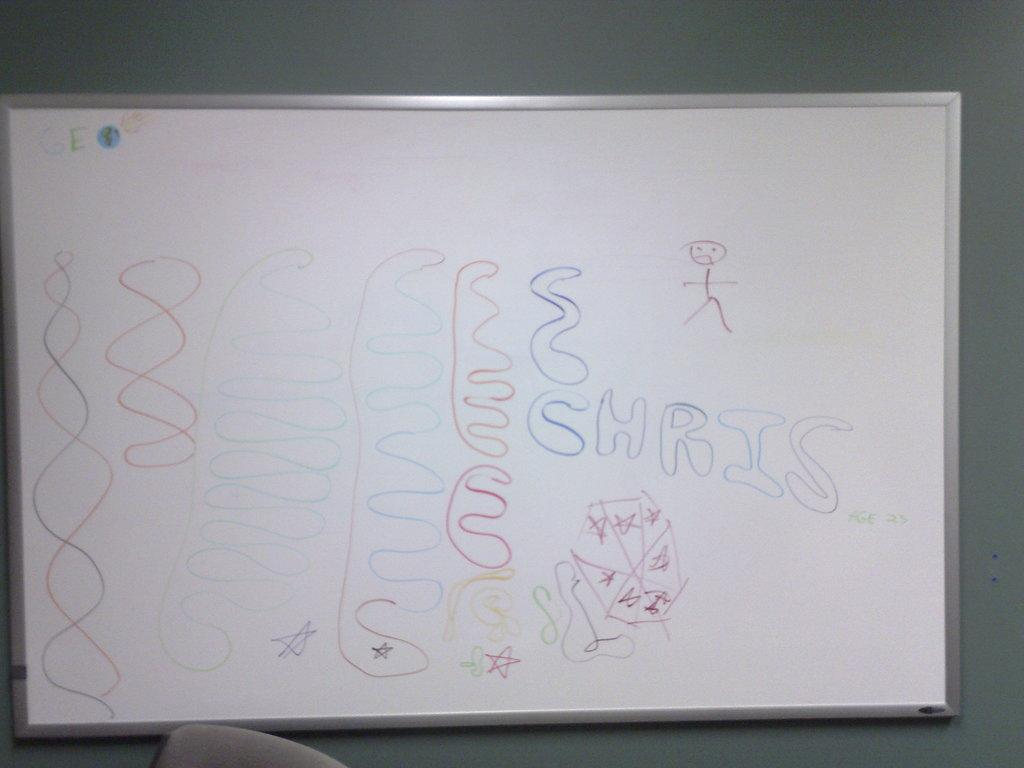Provide a one-sentence caption for the provided image. a write on wipe off whiteboard has drawings and the name Chris on it. 